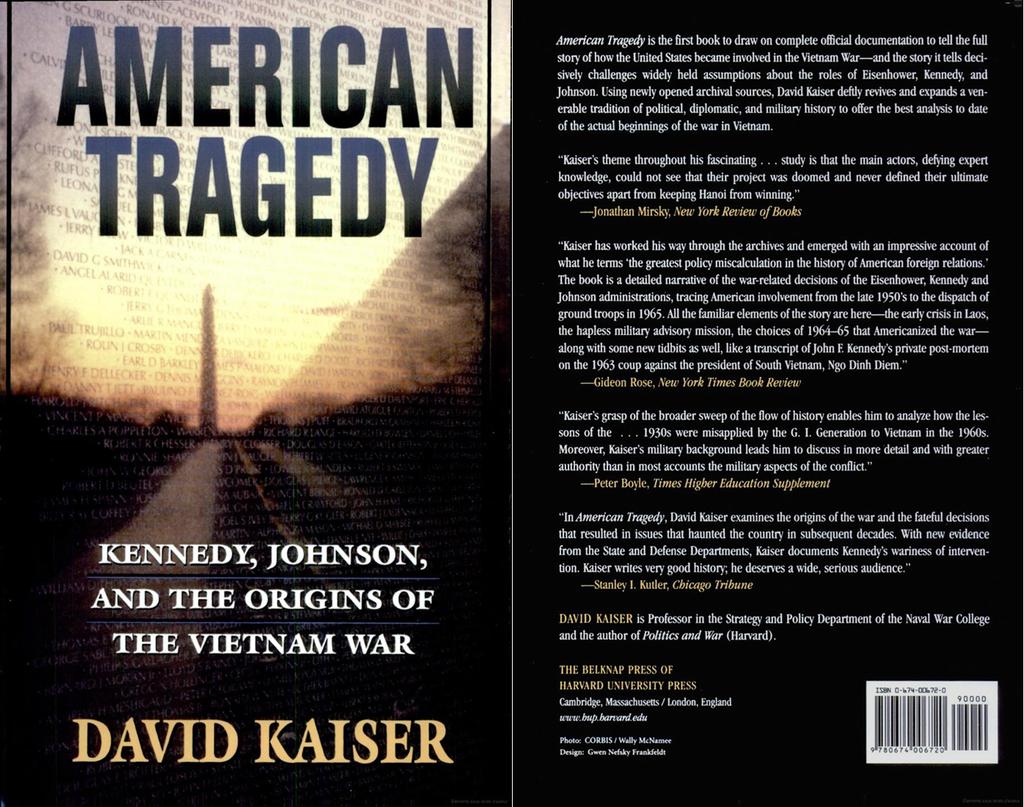What war does this book focus on?
Ensure brevity in your answer.  Vietnam war. What is the title of the book?
Provide a succinct answer. American tragedy. 